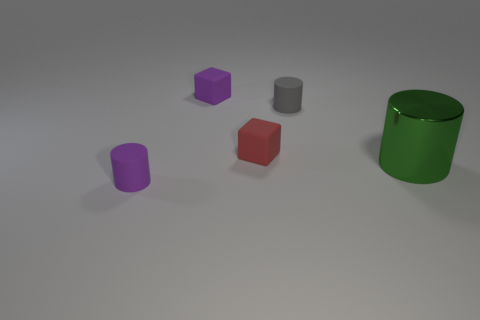What number of red things are either tiny rubber cylinders or small rubber blocks?
Offer a terse response. 1. Is the number of big green cylinders that are to the right of the red matte object the same as the number of big green metallic things?
Provide a succinct answer. Yes. There is a metal cylinder that is right of the tiny gray matte thing; what is its size?
Your answer should be compact. Large. How many other small matte things are the same shape as the red thing?
Give a very brief answer. 1. There is a object that is behind the small purple matte cylinder and in front of the small red matte block; what material is it?
Ensure brevity in your answer.  Metal. Are the gray cylinder and the big green object made of the same material?
Your answer should be compact. No. How many green objects are there?
Make the answer very short. 1. The tiny cylinder that is right of the small purple object in front of the tiny matte cylinder behind the green shiny cylinder is what color?
Provide a short and direct response. Gray. How many purple matte objects are both in front of the green thing and behind the tiny red thing?
Offer a very short reply. 0. How many metallic things are either small gray spheres or gray cylinders?
Your answer should be compact. 0. 